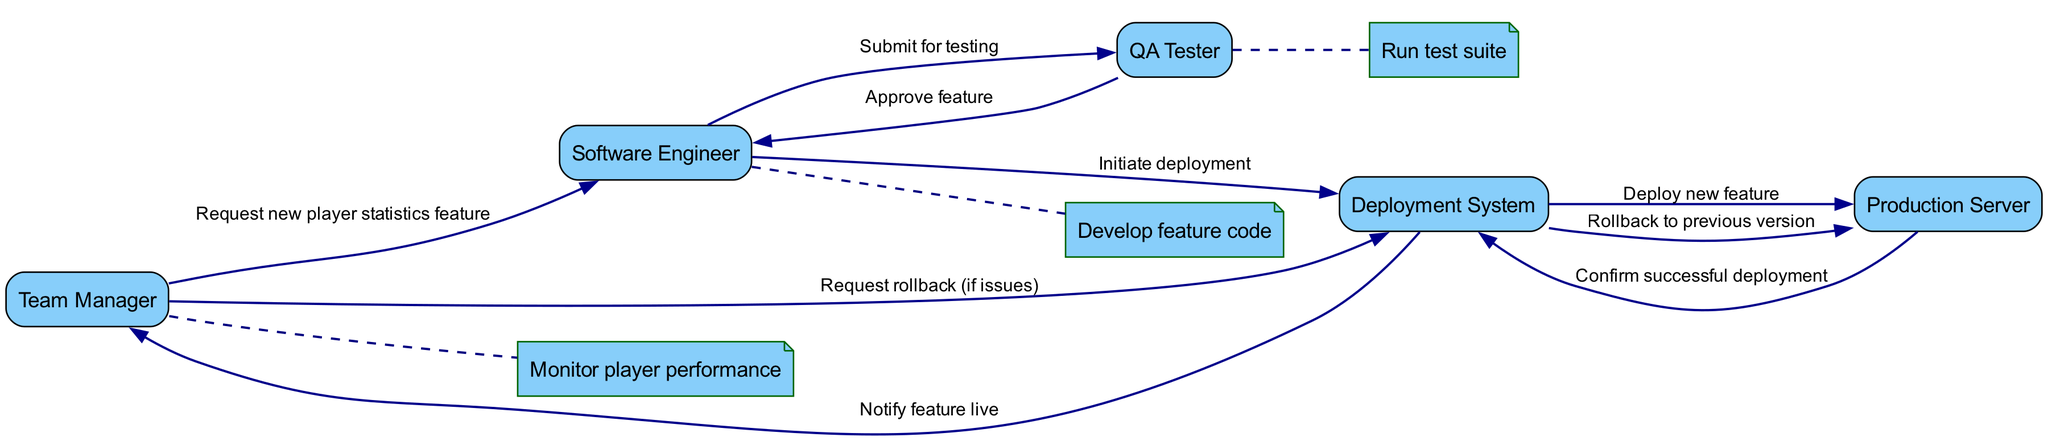What is the first action taken in the sequence? The first action depicted in the sequence is a request from the Team Manager to the Software Engineer for a new player statistics feature. This is illustrated by the edge connecting these two actors.
Answer: Request new player statistics feature How many actors are involved in the deployment process? The diagram lists five distinct actors who participate in the deployment process: Team Manager, Software Engineer, QA Tester, Deployment System, and Production Server. This can be directly counted by examining the nodes.
Answer: Five Which actor is responsible for approving the feature after testing? The QA Tester is the actor responsible for approving the feature after running the test suite. This is derived from the action where the QA Tester sends an approval to the Software Engineer.
Answer: QA Tester What is the last action taken before the Team Manager is notified that the feature is live? The last action taken before this notification is the confirmation of a successful deployment from the Production Server back to the Deployment System. This step is crucial, as it validates the deployment before notifying others.
Answer: Confirm successful deployment If the Team Manager requests a rollback, which system is responsible for executing it? The Deployment System is responsible for executing the rollback to the previous version when requested by the Team Manager. This is detailed in the action that follows the Team Manager's request.
Answer: Deployment System Which two actors are involved in the feature code development? The Software Engineer collaborates with themselves to develop the feature code, as indicated by the self-loop in which they handle the coding process independently. This is clearly shown by tracking the applicable actions by this actor.
Answer: Software Engineer How many distinct actions are performed from the point of testing to deployment? There are four distinct actions starting from the QA Tester running the test suite all the way through to notifying the Team Manager that the feature is live. This includes the testing, approval, initiation of deployment, and confirmation of deployment actions.
Answer: Four What triggers the QA Tester to begin testing? The action that triggers the QA Tester to begin testing is the submission of the feature code by the Software Engineer for testing. The transition from the Software Engineer to the QA Tester indicates this handoff.
Answer: Submit for testing What happens if issues are detected post-deployment? If issues are detected post-deployment, the Team Manager can request a rollback, leading the Deployment System to revert to the previous version on the Production Server. This depicts the contingency plan in the deployment process.
Answer: Rollback to previous version 